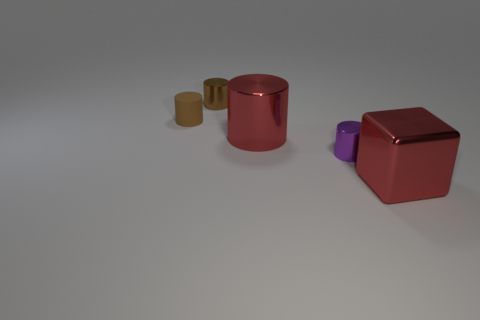Which object stands out the most and why? The large red glossy cube stands out the most due to its size, vibrant color, and shiny surface which contrasts with the matte finish of the other objects and catches the light differently. How does the lighting affect the appearance of the objects? The lighting creates subtle shadows and highlights, enhancing the perception of depth and texture. It makes the glossy surfaces, like the red cube, reflect more light, which makes them more visually prominent compared to the matte cylinders. 